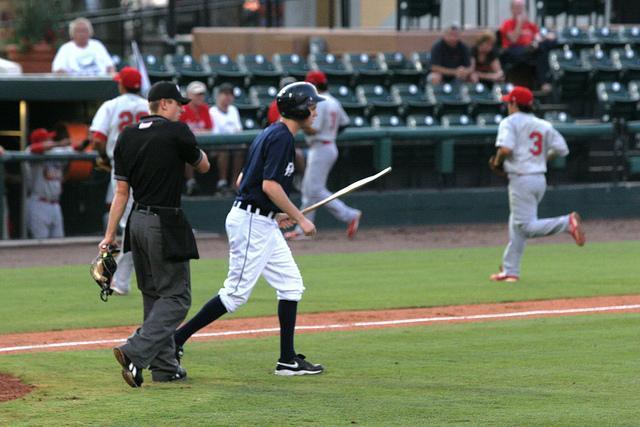How many people are there?
Give a very brief answer. 9. How many light color cars are there?
Give a very brief answer. 0. 